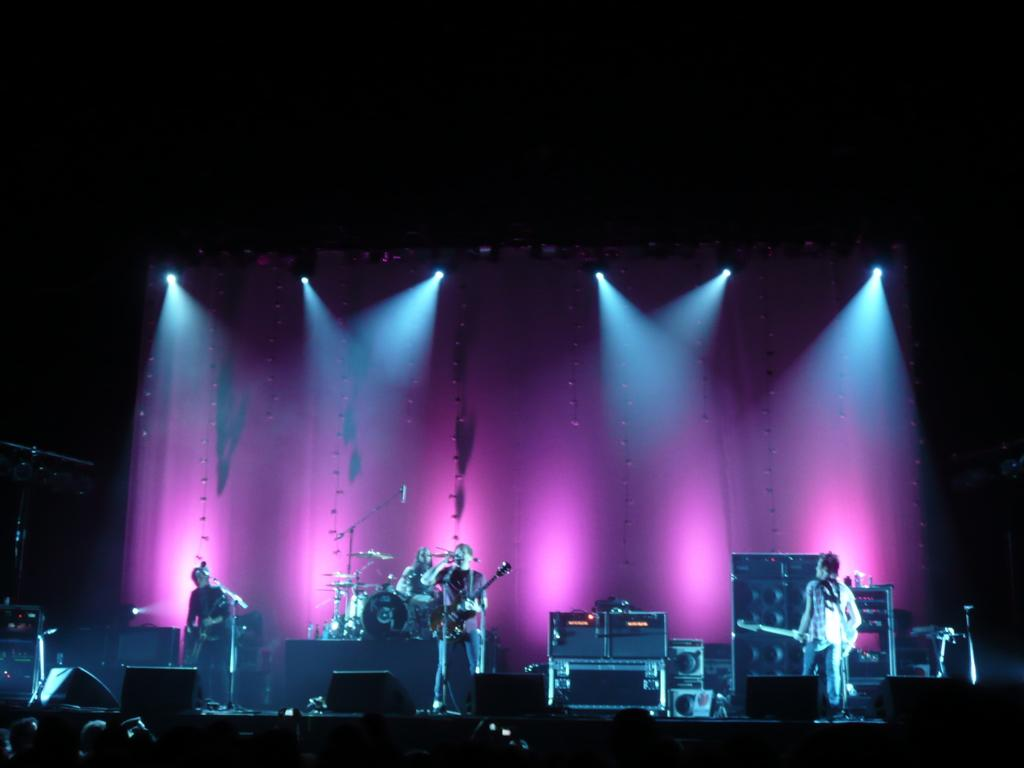What are the people in the image doing? The people in the image are holding musical instruments. What can be seen in the image besides the people with instruments? There are speakers visible in the image. What type of furniture is present in the image? There is a table in the image. What can be seen on the stage in the image? There are lights on the stage. Can you see a hill in the background of the image? There is no hill visible in the image. Are the people swimming with their musical instruments in the image? There is no swimming activity depicted in the image; the people are holding musical instruments. 